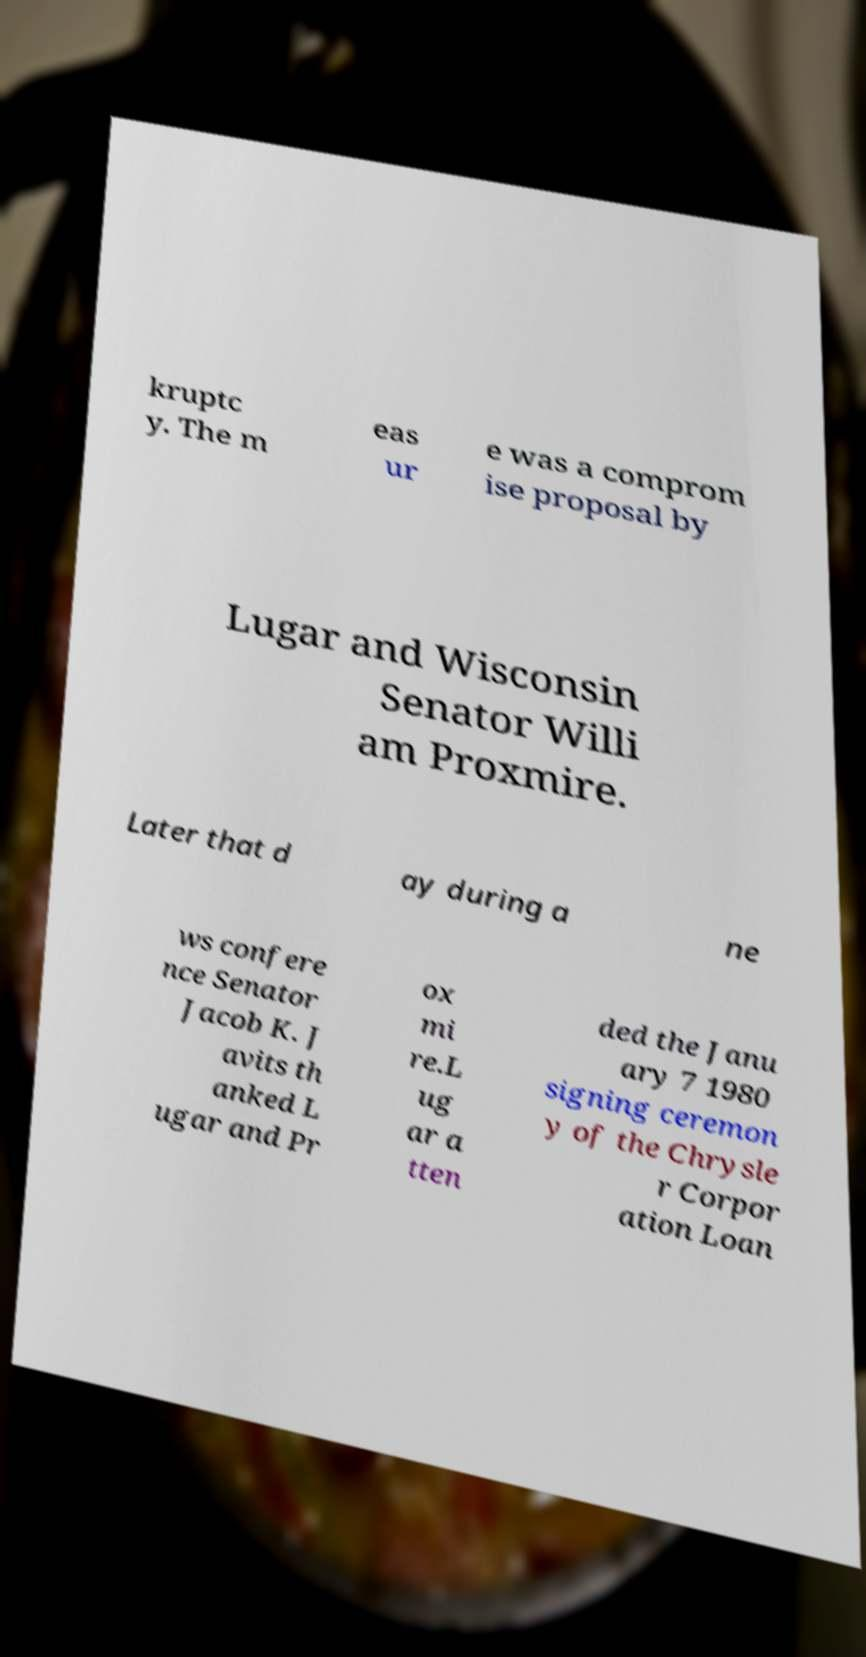I need the written content from this picture converted into text. Can you do that? kruptc y. The m eas ur e was a comprom ise proposal by Lugar and Wisconsin Senator Willi am Proxmire. Later that d ay during a ne ws confere nce Senator Jacob K. J avits th anked L ugar and Pr ox mi re.L ug ar a tten ded the Janu ary 7 1980 signing ceremon y of the Chrysle r Corpor ation Loan 